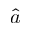<formula> <loc_0><loc_0><loc_500><loc_500>\hat { a }</formula> 